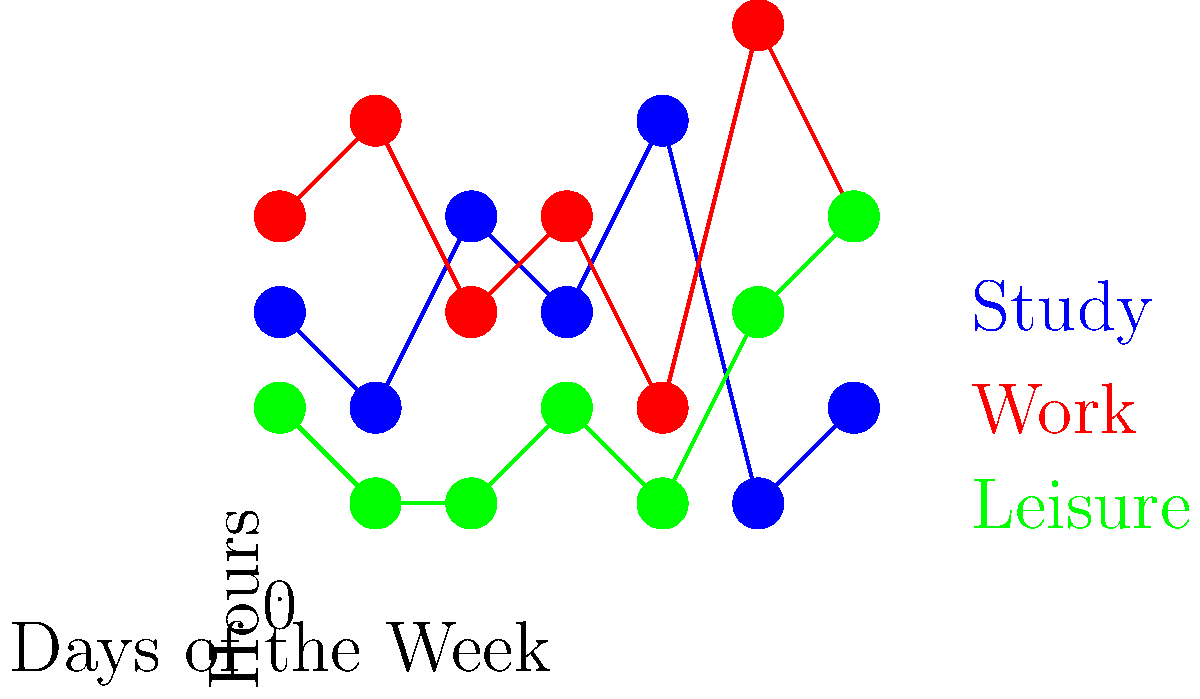As a successful college graduate who has managed anxiety and stress during your academic journey, analyze the weekly schedule diagram. On which day does the allocation of time for study, work, and leisure appear to be most balanced, potentially contributing to reduced stress levels? To determine the day with the most balanced time allocation, we need to examine each day's distribution of hours across study, work, and leisure activities. A balanced day would have relatively equal time spent on each activity, which could contribute to reduced stress levels.

Let's analyze each day:

1. Sunday (Day 0): Study 3h, Work 4h, Leisure 2h
2. Monday (Day 1): Study 2h, Work 5h, Leisure 1h
3. Tuesday (Day 2): Study 4h, Work 3h, Leisure 1h
4. Wednesday (Day 3): Study 3h, Work 4h, Leisure 2h
5. Thursday (Day 4): Study 5h, Work 2h, Leisure 1h
6. Friday (Day 5): Study 1h, Work 6h, Leisure 3h
7. Saturday (Day 6): Study 2h, Work 4h, Leisure 4h

The day with the most balanced distribution appears to be Wednesday (Day 3). On this day:
- Study: 3 hours
- Work: 4 hours
- Leisure: 2 hours

While not perfectly equal, this distribution shows a relatively balanced allocation of time across all three activities. The difference between the highest (work, 4h) and lowest (leisure, 2h) is only 2 hours, which is the smallest gap among all days.

This balance could potentially contribute to reduced stress levels by ensuring adequate time for academic responsibilities (study), professional development or part-time work (work), and relaxation or personal activities (leisure).
Answer: Wednesday (Day 3) 